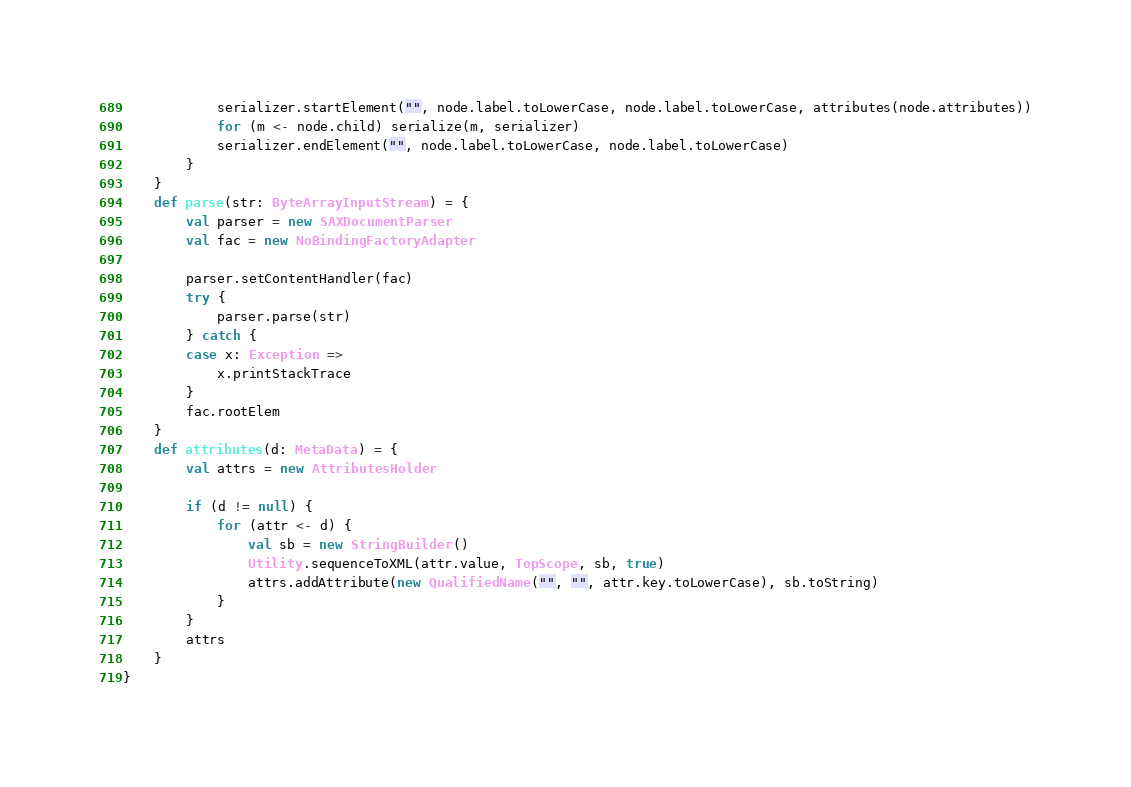<code> <loc_0><loc_0><loc_500><loc_500><_Scala_>			serializer.startElement("", node.label.toLowerCase, node.label.toLowerCase, attributes(node.attributes))
			for (m <- node.child) serialize(m, serializer)
			serializer.endElement("", node.label.toLowerCase, node.label.toLowerCase)
		}
	}
	def parse(str: ByteArrayInputStream) = {
		val parser = new SAXDocumentParser
		val fac = new NoBindingFactoryAdapter

		parser.setContentHandler(fac)
		try {
			parser.parse(str)
		} catch {
		case x: Exception =>
			x.printStackTrace
		}
		fac.rootElem
	}
	def attributes(d: MetaData) = {
		val attrs = new AttributesHolder

		if (d != null) {
			for (attr <- d) {
				val sb = new StringBuilder()
				Utility.sequenceToXML(attr.value, TopScope, sb, true)
				attrs.addAttribute(new QualifiedName("", "", attr.key.toLowerCase), sb.toString)
			}
		}
		attrs
	}
}
</code> 